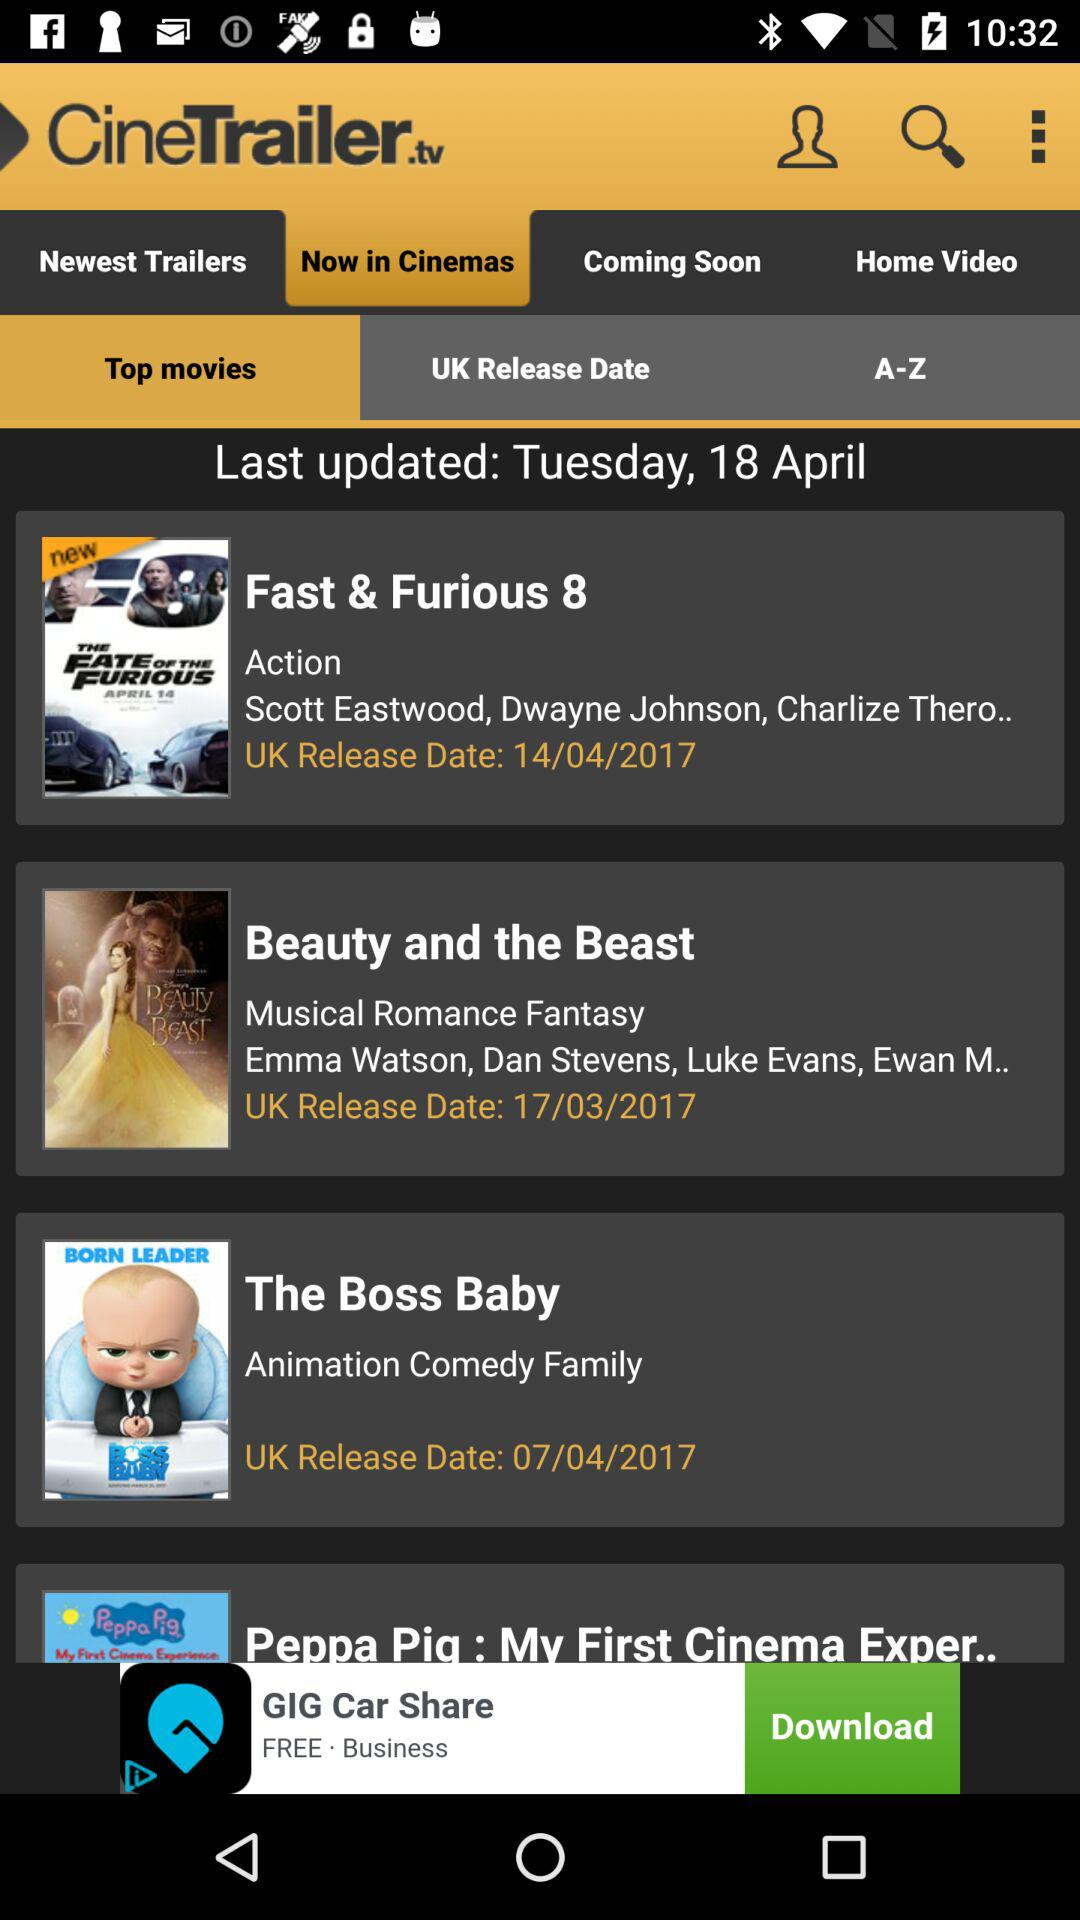What is the release date of "Fast & Furious 8"? The release date of "Fast & Furious 8" is April 14, 2017. 